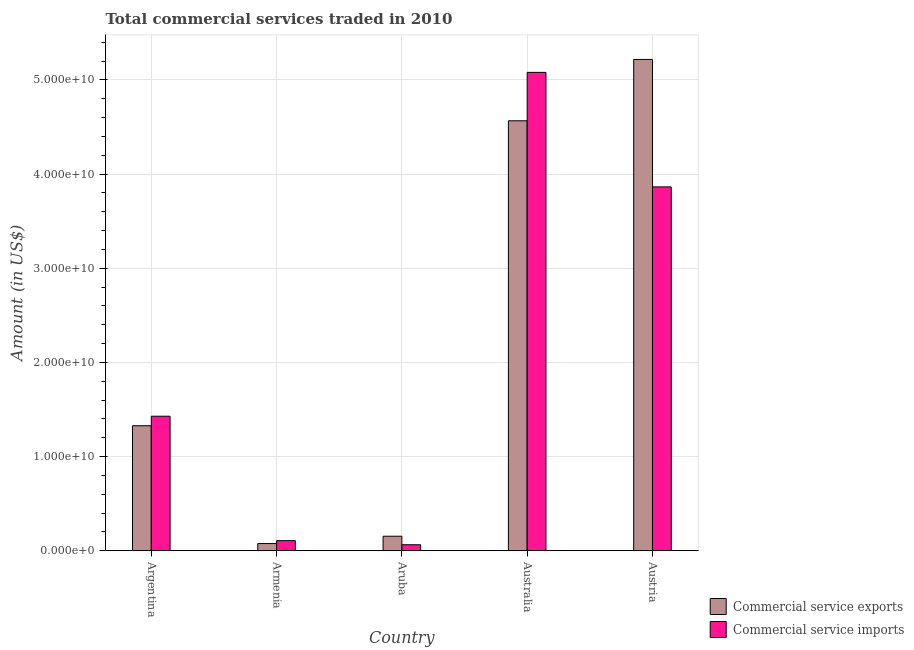How many different coloured bars are there?
Provide a succinct answer. 2. How many groups of bars are there?
Your answer should be very brief. 5. Are the number of bars per tick equal to the number of legend labels?
Ensure brevity in your answer.  Yes. Are the number of bars on each tick of the X-axis equal?
Offer a very short reply. Yes. How many bars are there on the 3rd tick from the left?
Ensure brevity in your answer.  2. How many bars are there on the 3rd tick from the right?
Offer a terse response. 2. What is the label of the 5th group of bars from the left?
Ensure brevity in your answer.  Austria. In how many cases, is the number of bars for a given country not equal to the number of legend labels?
Offer a very short reply. 0. What is the amount of commercial service imports in Aruba?
Offer a very short reply. 6.41e+08. Across all countries, what is the maximum amount of commercial service exports?
Offer a very short reply. 5.22e+1. Across all countries, what is the minimum amount of commercial service exports?
Your response must be concise. 7.66e+08. In which country was the amount of commercial service exports maximum?
Give a very brief answer. Austria. In which country was the amount of commercial service exports minimum?
Provide a succinct answer. Armenia. What is the total amount of commercial service imports in the graph?
Provide a short and direct response. 1.05e+11. What is the difference between the amount of commercial service exports in Aruba and that in Australia?
Your response must be concise. -4.41e+1. What is the difference between the amount of commercial service imports in Armenia and the amount of commercial service exports in Austria?
Your answer should be compact. -5.11e+1. What is the average amount of commercial service imports per country?
Ensure brevity in your answer.  2.11e+1. What is the difference between the amount of commercial service exports and amount of commercial service imports in Australia?
Offer a terse response. -5.14e+09. In how many countries, is the amount of commercial service imports greater than 36000000000 US$?
Offer a very short reply. 2. What is the ratio of the amount of commercial service imports in Armenia to that in Aruba?
Your response must be concise. 1.67. Is the difference between the amount of commercial service exports in Armenia and Australia greater than the difference between the amount of commercial service imports in Armenia and Australia?
Make the answer very short. Yes. What is the difference between the highest and the second highest amount of commercial service imports?
Ensure brevity in your answer.  1.22e+1. What is the difference between the highest and the lowest amount of commercial service exports?
Offer a terse response. 5.14e+1. What does the 2nd bar from the left in Australia represents?
Your response must be concise. Commercial service imports. What does the 2nd bar from the right in Aruba represents?
Make the answer very short. Commercial service exports. Are all the bars in the graph horizontal?
Offer a terse response. No. What is the difference between two consecutive major ticks on the Y-axis?
Offer a terse response. 1.00e+1. Does the graph contain any zero values?
Give a very brief answer. No. What is the title of the graph?
Keep it short and to the point. Total commercial services traded in 2010. What is the Amount (in US$) in Commercial service exports in Argentina?
Keep it short and to the point. 1.33e+1. What is the Amount (in US$) of Commercial service imports in Argentina?
Keep it short and to the point. 1.43e+1. What is the Amount (in US$) in Commercial service exports in Armenia?
Offer a very short reply. 7.66e+08. What is the Amount (in US$) in Commercial service imports in Armenia?
Your response must be concise. 1.07e+09. What is the Amount (in US$) in Commercial service exports in Aruba?
Your answer should be very brief. 1.55e+09. What is the Amount (in US$) in Commercial service imports in Aruba?
Keep it short and to the point. 6.41e+08. What is the Amount (in US$) in Commercial service exports in Australia?
Offer a very short reply. 4.57e+1. What is the Amount (in US$) in Commercial service imports in Australia?
Provide a succinct answer. 5.08e+1. What is the Amount (in US$) in Commercial service exports in Austria?
Offer a terse response. 5.22e+1. What is the Amount (in US$) in Commercial service imports in Austria?
Make the answer very short. 3.86e+1. Across all countries, what is the maximum Amount (in US$) in Commercial service exports?
Provide a succinct answer. 5.22e+1. Across all countries, what is the maximum Amount (in US$) of Commercial service imports?
Your answer should be very brief. 5.08e+1. Across all countries, what is the minimum Amount (in US$) of Commercial service exports?
Your response must be concise. 7.66e+08. Across all countries, what is the minimum Amount (in US$) in Commercial service imports?
Provide a short and direct response. 6.41e+08. What is the total Amount (in US$) of Commercial service exports in the graph?
Your response must be concise. 1.13e+11. What is the total Amount (in US$) of Commercial service imports in the graph?
Ensure brevity in your answer.  1.05e+11. What is the difference between the Amount (in US$) of Commercial service exports in Argentina and that in Armenia?
Make the answer very short. 1.25e+1. What is the difference between the Amount (in US$) in Commercial service imports in Argentina and that in Armenia?
Your response must be concise. 1.32e+1. What is the difference between the Amount (in US$) of Commercial service exports in Argentina and that in Aruba?
Give a very brief answer. 1.17e+1. What is the difference between the Amount (in US$) in Commercial service imports in Argentina and that in Aruba?
Provide a succinct answer. 1.36e+1. What is the difference between the Amount (in US$) in Commercial service exports in Argentina and that in Australia?
Your response must be concise. -3.24e+1. What is the difference between the Amount (in US$) in Commercial service imports in Argentina and that in Australia?
Your response must be concise. -3.65e+1. What is the difference between the Amount (in US$) in Commercial service exports in Argentina and that in Austria?
Offer a terse response. -3.89e+1. What is the difference between the Amount (in US$) in Commercial service imports in Argentina and that in Austria?
Ensure brevity in your answer.  -2.44e+1. What is the difference between the Amount (in US$) of Commercial service exports in Armenia and that in Aruba?
Offer a terse response. -7.79e+08. What is the difference between the Amount (in US$) in Commercial service imports in Armenia and that in Aruba?
Offer a very short reply. 4.33e+08. What is the difference between the Amount (in US$) of Commercial service exports in Armenia and that in Australia?
Make the answer very short. -4.49e+1. What is the difference between the Amount (in US$) of Commercial service imports in Armenia and that in Australia?
Ensure brevity in your answer.  -4.97e+1. What is the difference between the Amount (in US$) of Commercial service exports in Armenia and that in Austria?
Offer a very short reply. -5.14e+1. What is the difference between the Amount (in US$) in Commercial service imports in Armenia and that in Austria?
Ensure brevity in your answer.  -3.76e+1. What is the difference between the Amount (in US$) of Commercial service exports in Aruba and that in Australia?
Ensure brevity in your answer.  -4.41e+1. What is the difference between the Amount (in US$) in Commercial service imports in Aruba and that in Australia?
Your response must be concise. -5.02e+1. What is the difference between the Amount (in US$) in Commercial service exports in Aruba and that in Austria?
Provide a succinct answer. -5.06e+1. What is the difference between the Amount (in US$) in Commercial service imports in Aruba and that in Austria?
Your response must be concise. -3.80e+1. What is the difference between the Amount (in US$) in Commercial service exports in Australia and that in Austria?
Your answer should be compact. -6.51e+09. What is the difference between the Amount (in US$) in Commercial service imports in Australia and that in Austria?
Keep it short and to the point. 1.22e+1. What is the difference between the Amount (in US$) in Commercial service exports in Argentina and the Amount (in US$) in Commercial service imports in Armenia?
Offer a terse response. 1.22e+1. What is the difference between the Amount (in US$) of Commercial service exports in Argentina and the Amount (in US$) of Commercial service imports in Aruba?
Provide a succinct answer. 1.26e+1. What is the difference between the Amount (in US$) in Commercial service exports in Argentina and the Amount (in US$) in Commercial service imports in Australia?
Offer a very short reply. -3.75e+1. What is the difference between the Amount (in US$) of Commercial service exports in Argentina and the Amount (in US$) of Commercial service imports in Austria?
Offer a very short reply. -2.54e+1. What is the difference between the Amount (in US$) in Commercial service exports in Armenia and the Amount (in US$) in Commercial service imports in Aruba?
Your answer should be compact. 1.25e+08. What is the difference between the Amount (in US$) in Commercial service exports in Armenia and the Amount (in US$) in Commercial service imports in Australia?
Ensure brevity in your answer.  -5.00e+1. What is the difference between the Amount (in US$) in Commercial service exports in Armenia and the Amount (in US$) in Commercial service imports in Austria?
Your answer should be compact. -3.79e+1. What is the difference between the Amount (in US$) of Commercial service exports in Aruba and the Amount (in US$) of Commercial service imports in Australia?
Offer a terse response. -4.93e+1. What is the difference between the Amount (in US$) in Commercial service exports in Aruba and the Amount (in US$) in Commercial service imports in Austria?
Make the answer very short. -3.71e+1. What is the difference between the Amount (in US$) of Commercial service exports in Australia and the Amount (in US$) of Commercial service imports in Austria?
Make the answer very short. 7.02e+09. What is the average Amount (in US$) of Commercial service exports per country?
Your answer should be compact. 2.27e+1. What is the average Amount (in US$) in Commercial service imports per country?
Give a very brief answer. 2.11e+1. What is the difference between the Amount (in US$) in Commercial service exports and Amount (in US$) in Commercial service imports in Argentina?
Offer a terse response. -1.01e+09. What is the difference between the Amount (in US$) in Commercial service exports and Amount (in US$) in Commercial service imports in Armenia?
Provide a short and direct response. -3.07e+08. What is the difference between the Amount (in US$) in Commercial service exports and Amount (in US$) in Commercial service imports in Aruba?
Your answer should be very brief. 9.04e+08. What is the difference between the Amount (in US$) of Commercial service exports and Amount (in US$) of Commercial service imports in Australia?
Keep it short and to the point. -5.14e+09. What is the difference between the Amount (in US$) in Commercial service exports and Amount (in US$) in Commercial service imports in Austria?
Your answer should be very brief. 1.35e+1. What is the ratio of the Amount (in US$) of Commercial service exports in Argentina to that in Armenia?
Make the answer very short. 17.33. What is the ratio of the Amount (in US$) of Commercial service imports in Argentina to that in Armenia?
Make the answer very short. 13.31. What is the ratio of the Amount (in US$) of Commercial service exports in Argentina to that in Aruba?
Provide a short and direct response. 8.59. What is the ratio of the Amount (in US$) of Commercial service imports in Argentina to that in Aruba?
Your answer should be very brief. 22.29. What is the ratio of the Amount (in US$) in Commercial service exports in Argentina to that in Australia?
Provide a succinct answer. 0.29. What is the ratio of the Amount (in US$) in Commercial service imports in Argentina to that in Australia?
Give a very brief answer. 0.28. What is the ratio of the Amount (in US$) of Commercial service exports in Argentina to that in Austria?
Offer a terse response. 0.25. What is the ratio of the Amount (in US$) of Commercial service imports in Argentina to that in Austria?
Keep it short and to the point. 0.37. What is the ratio of the Amount (in US$) of Commercial service exports in Armenia to that in Aruba?
Your answer should be compact. 0.5. What is the ratio of the Amount (in US$) in Commercial service imports in Armenia to that in Aruba?
Offer a very short reply. 1.67. What is the ratio of the Amount (in US$) of Commercial service exports in Armenia to that in Australia?
Give a very brief answer. 0.02. What is the ratio of the Amount (in US$) of Commercial service imports in Armenia to that in Australia?
Provide a succinct answer. 0.02. What is the ratio of the Amount (in US$) of Commercial service exports in Armenia to that in Austria?
Offer a very short reply. 0.01. What is the ratio of the Amount (in US$) of Commercial service imports in Armenia to that in Austria?
Provide a short and direct response. 0.03. What is the ratio of the Amount (in US$) in Commercial service exports in Aruba to that in Australia?
Make the answer very short. 0.03. What is the ratio of the Amount (in US$) of Commercial service imports in Aruba to that in Australia?
Give a very brief answer. 0.01. What is the ratio of the Amount (in US$) of Commercial service exports in Aruba to that in Austria?
Give a very brief answer. 0.03. What is the ratio of the Amount (in US$) of Commercial service imports in Aruba to that in Austria?
Make the answer very short. 0.02. What is the ratio of the Amount (in US$) of Commercial service exports in Australia to that in Austria?
Make the answer very short. 0.88. What is the ratio of the Amount (in US$) of Commercial service imports in Australia to that in Austria?
Your answer should be very brief. 1.31. What is the difference between the highest and the second highest Amount (in US$) of Commercial service exports?
Your response must be concise. 6.51e+09. What is the difference between the highest and the second highest Amount (in US$) in Commercial service imports?
Give a very brief answer. 1.22e+1. What is the difference between the highest and the lowest Amount (in US$) in Commercial service exports?
Make the answer very short. 5.14e+1. What is the difference between the highest and the lowest Amount (in US$) in Commercial service imports?
Offer a very short reply. 5.02e+1. 